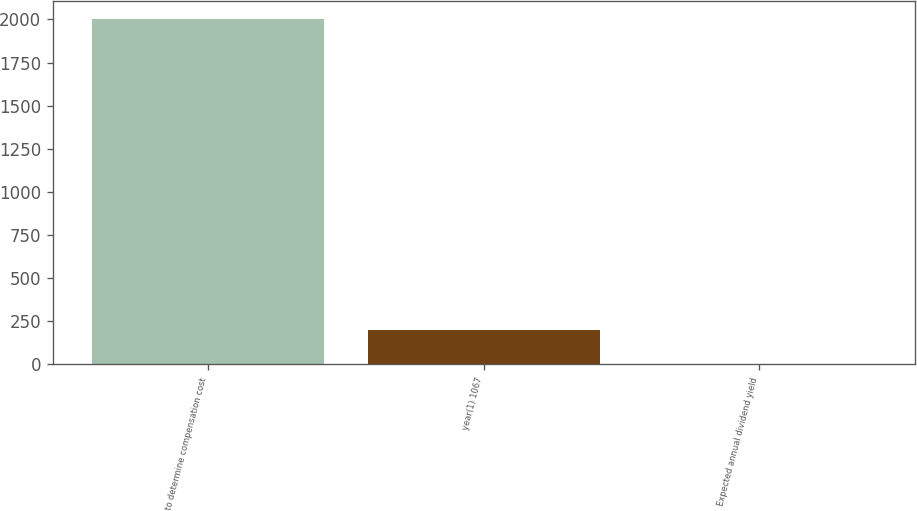Convert chart to OTSL. <chart><loc_0><loc_0><loc_500><loc_500><bar_chart><fcel>to determine compensation cost<fcel>year(1) 1067<fcel>Expected annual dividend yield<nl><fcel>2004<fcel>202.29<fcel>2.1<nl></chart> 